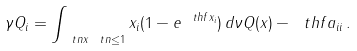<formula> <loc_0><loc_0><loc_500><loc_500>\gamma Q _ { i } = \int _ { \ t n x \ t n \leq 1 } x _ { i } ( 1 - e ^ { \ t h f x _ { i } } ) \, d \nu Q ( x ) - \ t h f a _ { i i } \, .</formula> 